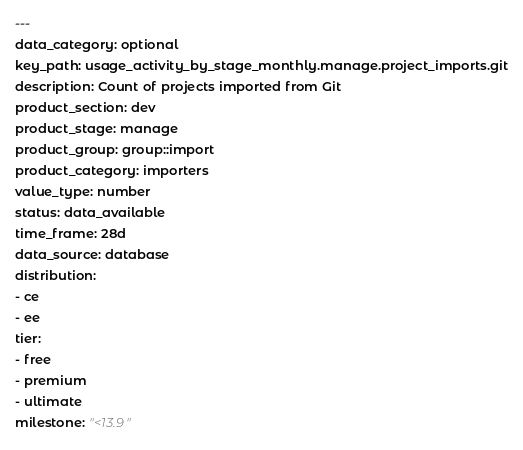Convert code to text. <code><loc_0><loc_0><loc_500><loc_500><_YAML_>---
data_category: optional
key_path: usage_activity_by_stage_monthly.manage.project_imports.git
description: Count of projects imported from Git
product_section: dev
product_stage: manage
product_group: group::import
product_category: importers
value_type: number
status: data_available
time_frame: 28d
data_source: database
distribution:
- ce
- ee
tier:
- free
- premium
- ultimate
milestone: "<13.9"
</code> 